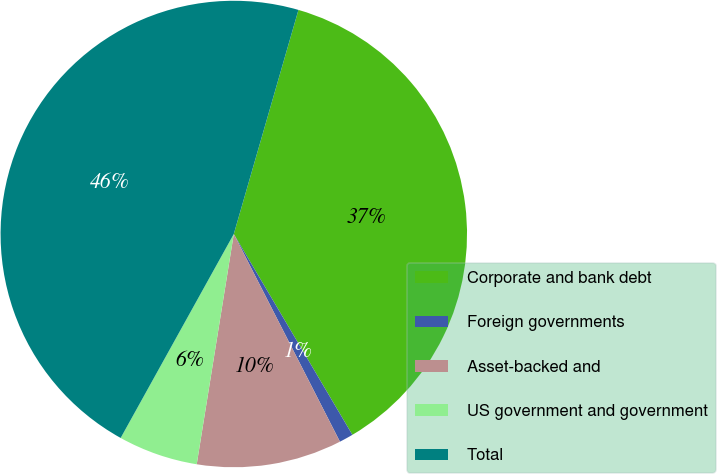<chart> <loc_0><loc_0><loc_500><loc_500><pie_chart><fcel>Corporate and bank debt<fcel>Foreign governments<fcel>Asset-backed and<fcel>US government and government<fcel>Total<nl><fcel>37.04%<fcel>0.97%<fcel>10.06%<fcel>5.52%<fcel>46.41%<nl></chart> 